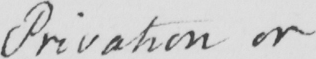Transcribe the text shown in this historical manuscript line. Privation or 